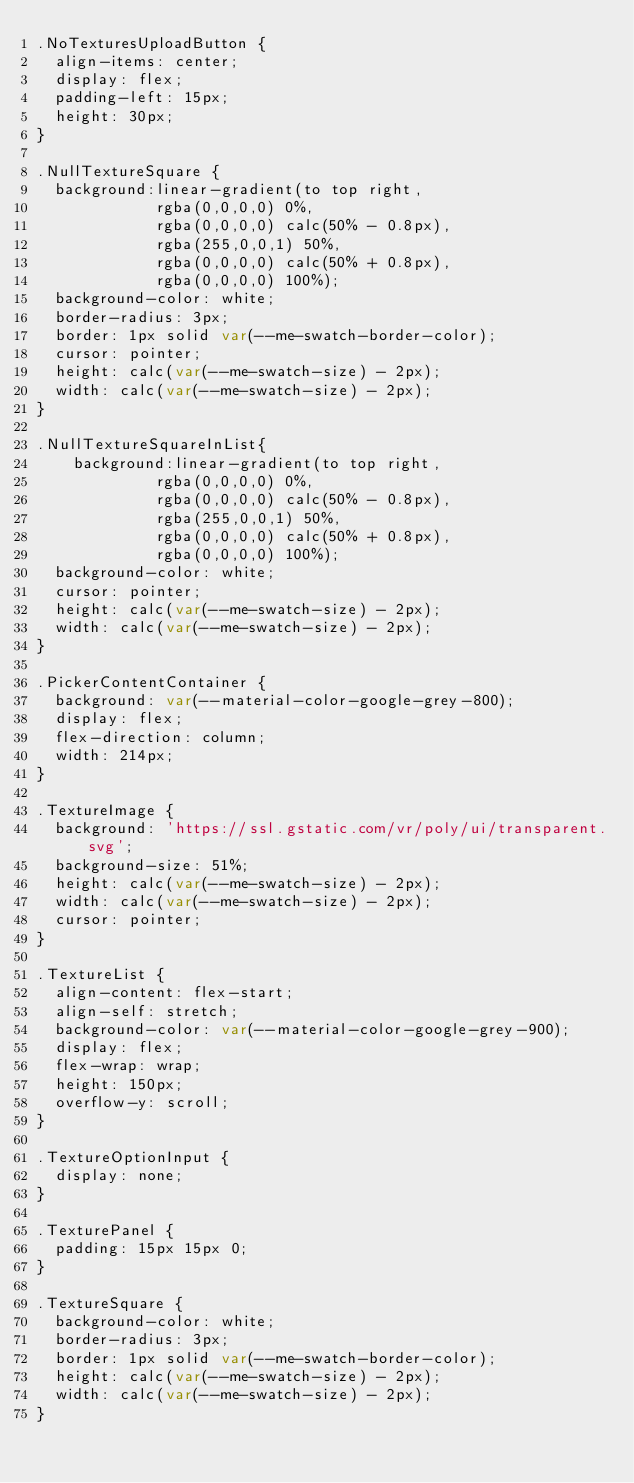<code> <loc_0><loc_0><loc_500><loc_500><_TypeScript_>.NoTexturesUploadButton {
  align-items: center;
  display: flex;
  padding-left: 15px;
  height: 30px;
}

.NullTextureSquare {
  background:linear-gradient(to top right,
             rgba(0,0,0,0) 0%,
             rgba(0,0,0,0) calc(50% - 0.8px),
             rgba(255,0,0,1) 50%,
             rgba(0,0,0,0) calc(50% + 0.8px),
             rgba(0,0,0,0) 100%);
  background-color: white;
  border-radius: 3px;
  border: 1px solid var(--me-swatch-border-color);
  cursor: pointer;
  height: calc(var(--me-swatch-size) - 2px);
  width: calc(var(--me-swatch-size) - 2px);
}

.NullTextureSquareInList{
    background:linear-gradient(to top right,
             rgba(0,0,0,0) 0%,
             rgba(0,0,0,0) calc(50% - 0.8px),
             rgba(255,0,0,1) 50%,
             rgba(0,0,0,0) calc(50% + 0.8px),
             rgba(0,0,0,0) 100%);
  background-color: white;
  cursor: pointer;
  height: calc(var(--me-swatch-size) - 2px);
  width: calc(var(--me-swatch-size) - 2px);
}

.PickerContentContainer {
  background: var(--material-color-google-grey-800);
  display: flex;
  flex-direction: column;
  width: 214px;
}

.TextureImage {
  background: 'https://ssl.gstatic.com/vr/poly/ui/transparent.svg';
  background-size: 51%;
  height: calc(var(--me-swatch-size) - 2px);
  width: calc(var(--me-swatch-size) - 2px);
  cursor: pointer;
}

.TextureList {
  align-content: flex-start;
  align-self: stretch;
  background-color: var(--material-color-google-grey-900);
  display: flex;
  flex-wrap: wrap;
  height: 150px;
  overflow-y: scroll;
}

.TextureOptionInput {
  display: none;
}

.TexturePanel {
  padding: 15px 15px 0;
}

.TextureSquare {
  background-color: white;
  border-radius: 3px;
  border: 1px solid var(--me-swatch-border-color);
  height: calc(var(--me-swatch-size) - 2px);
  width: calc(var(--me-swatch-size) - 2px);
}
</code> 